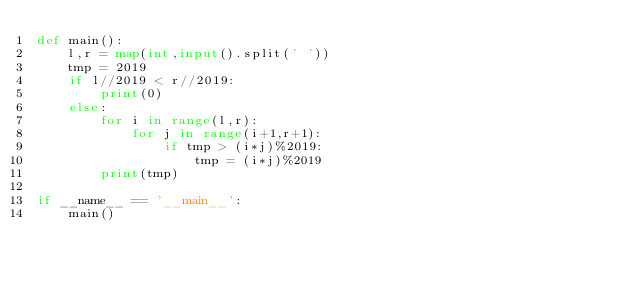Convert code to text. <code><loc_0><loc_0><loc_500><loc_500><_Python_>def main():
    l,r = map(int,input().split(' '))
    tmp = 2019
    if l//2019 < r//2019:
        print(0)
    else:
        for i in range(l,r):
            for j in range(i+1,r+1):
                if tmp > (i*j)%2019:
                    tmp = (i*j)%2019
        print(tmp)

if __name__ == '__main__':
    main()</code> 